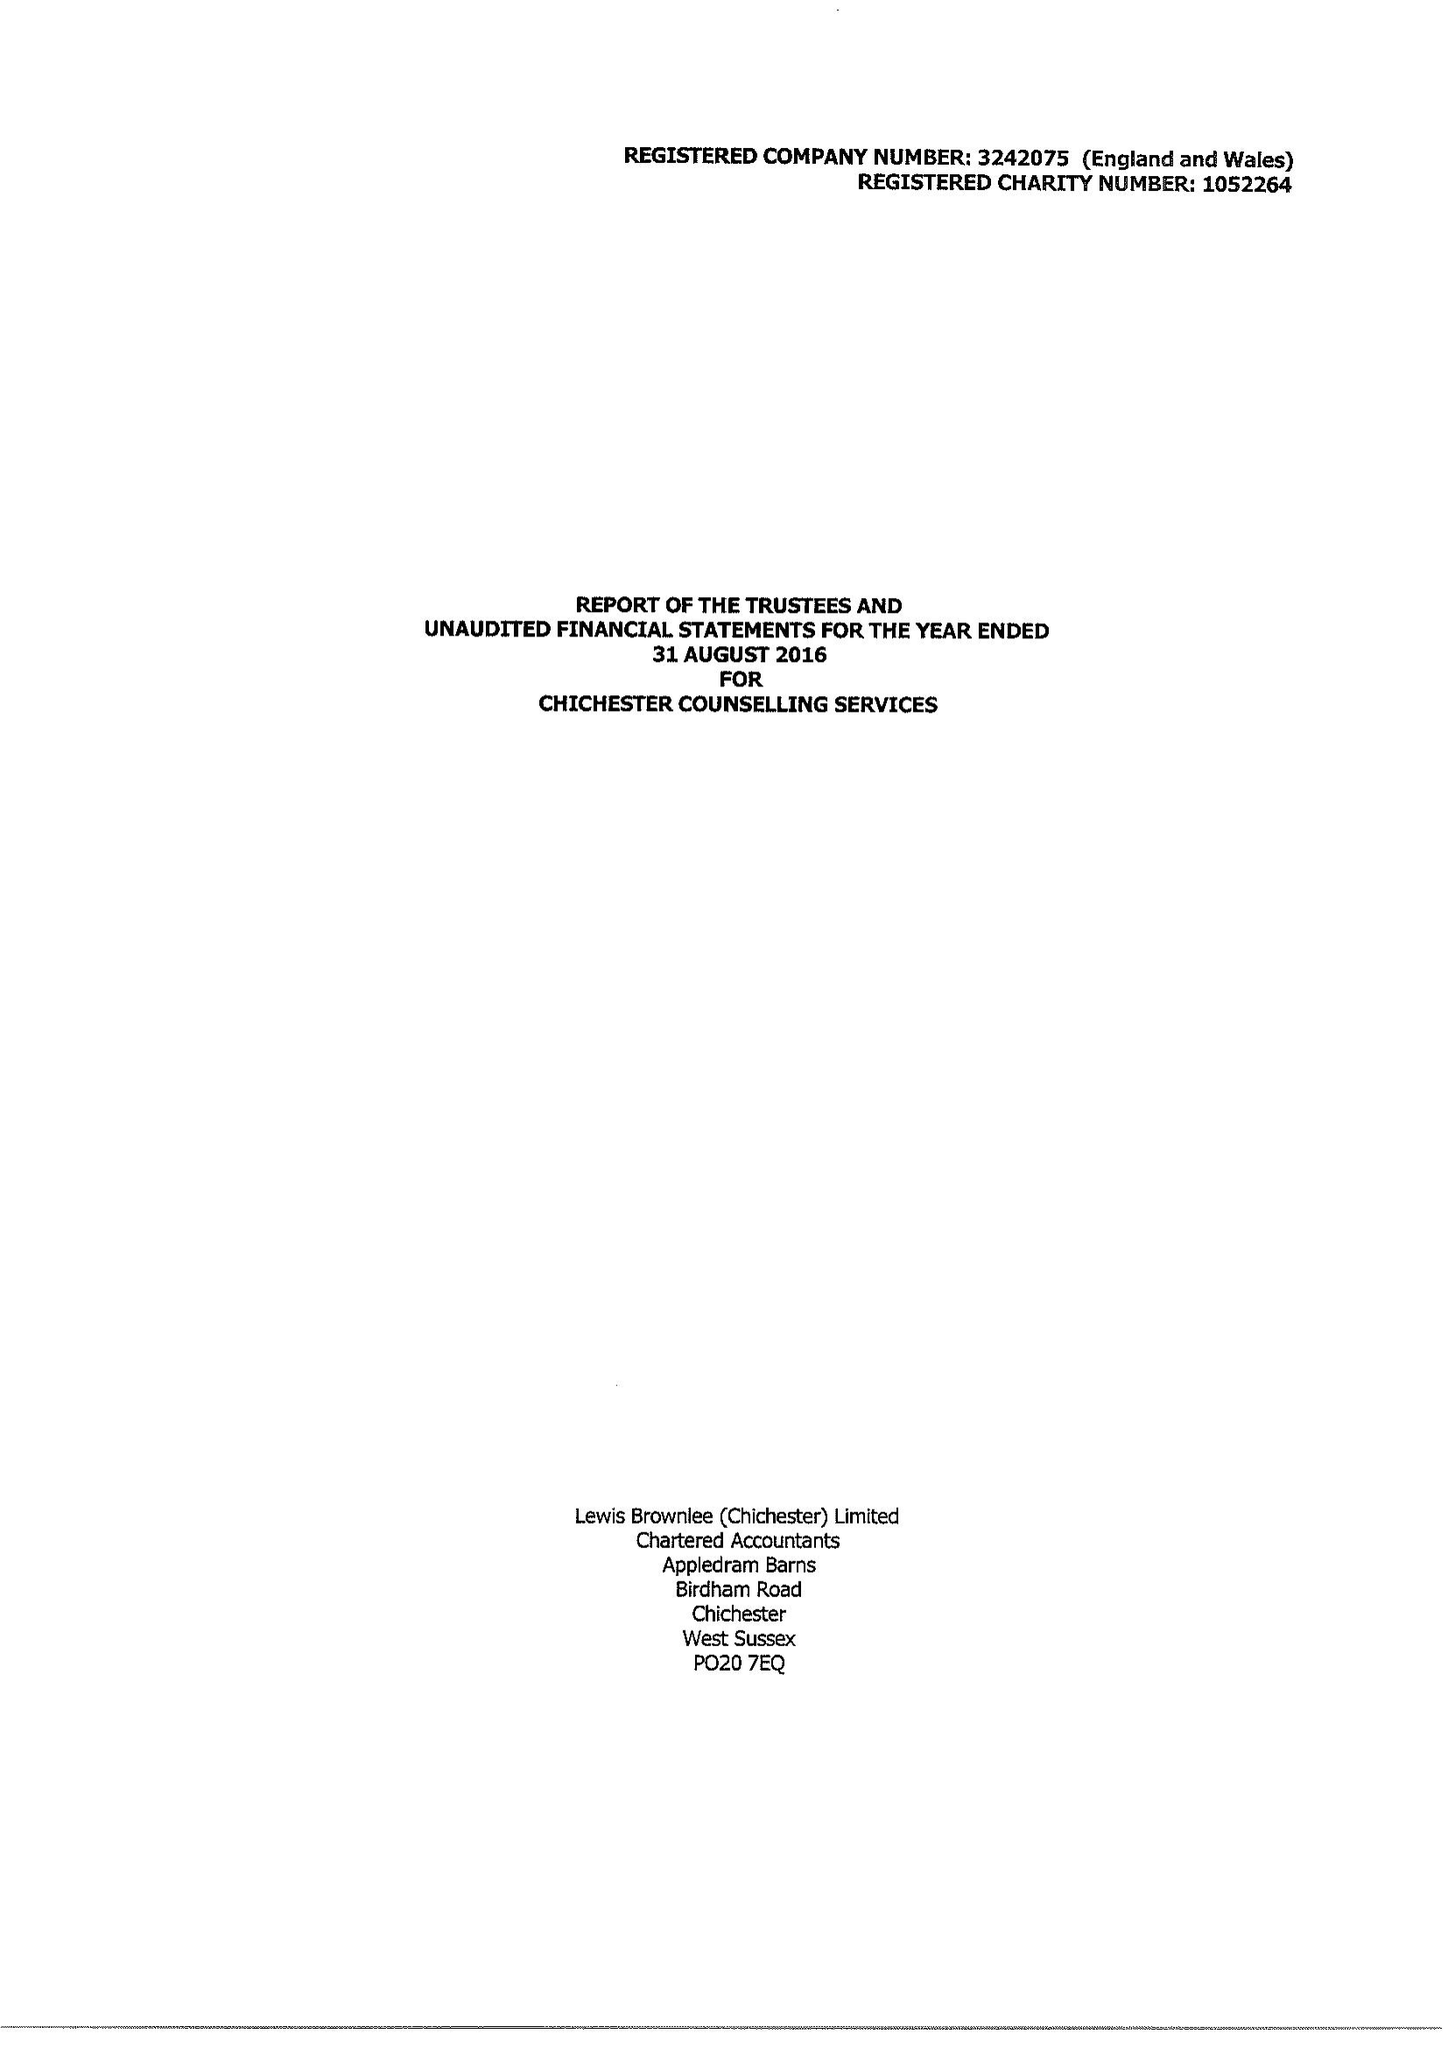What is the value for the report_date?
Answer the question using a single word or phrase. 2016-08-31 